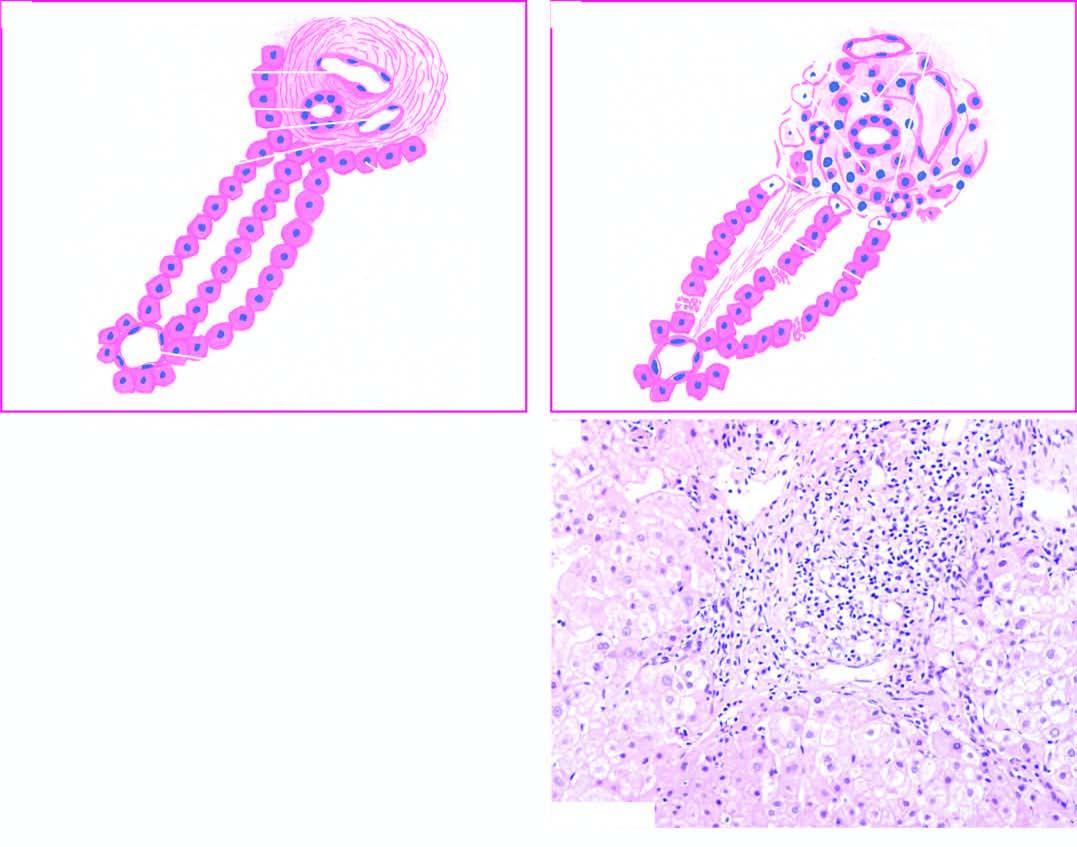does extension of fibrous spur into lobules?
Answer the question using a single word or phrase. Yes 